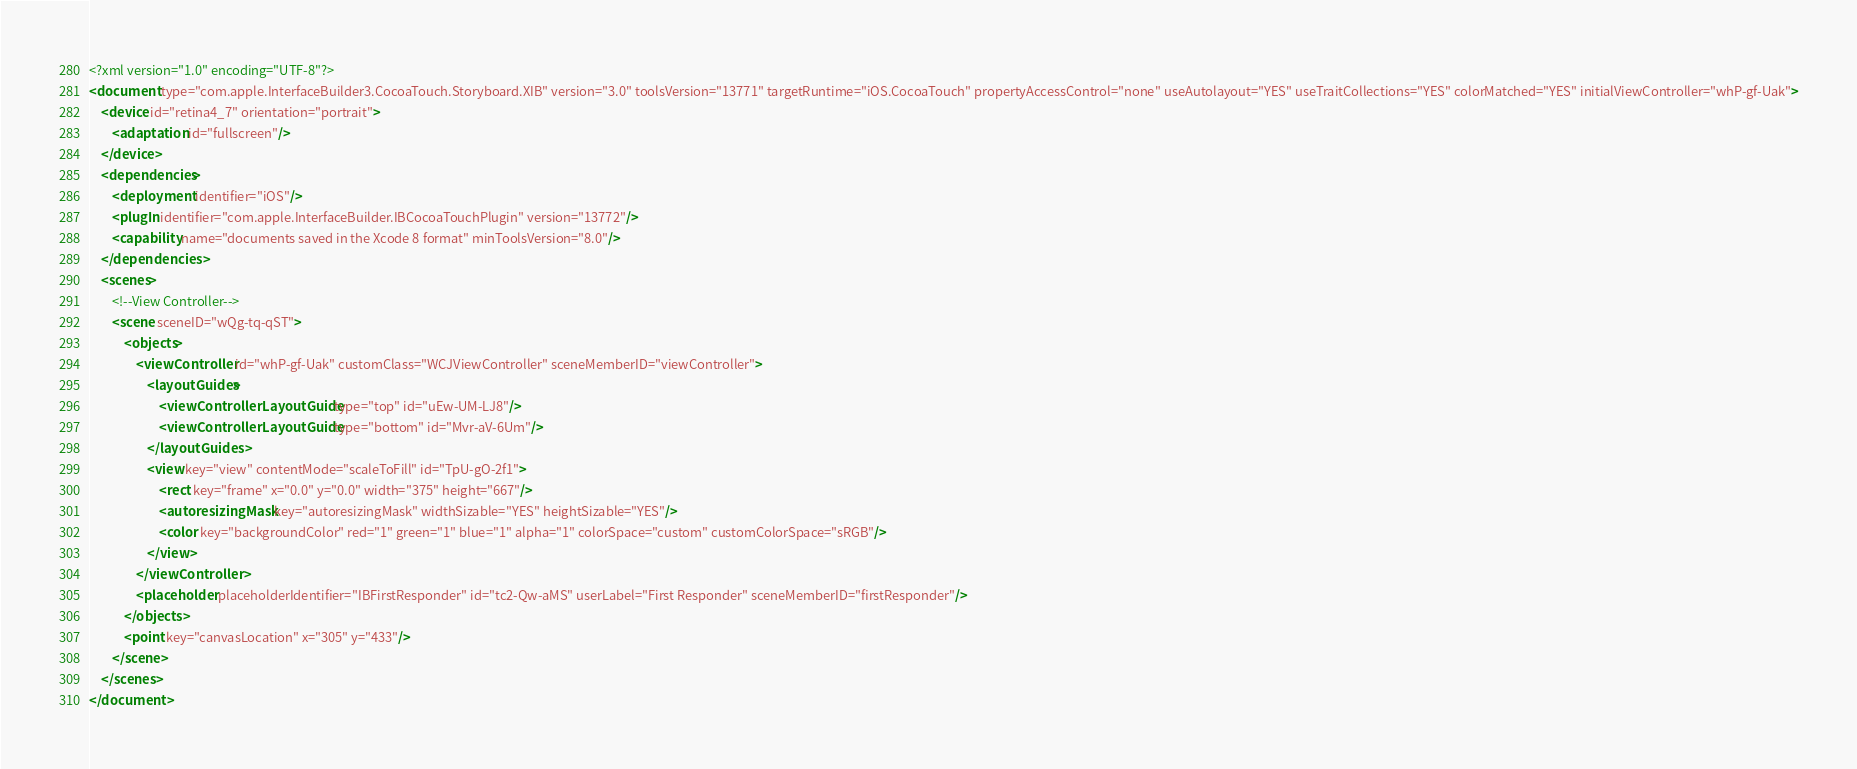<code> <loc_0><loc_0><loc_500><loc_500><_XML_><?xml version="1.0" encoding="UTF-8"?>
<document type="com.apple.InterfaceBuilder3.CocoaTouch.Storyboard.XIB" version="3.0" toolsVersion="13771" targetRuntime="iOS.CocoaTouch" propertyAccessControl="none" useAutolayout="YES" useTraitCollections="YES" colorMatched="YES" initialViewController="whP-gf-Uak">
    <device id="retina4_7" orientation="portrait">
        <adaptation id="fullscreen"/>
    </device>
    <dependencies>
        <deployment identifier="iOS"/>
        <plugIn identifier="com.apple.InterfaceBuilder.IBCocoaTouchPlugin" version="13772"/>
        <capability name="documents saved in the Xcode 8 format" minToolsVersion="8.0"/>
    </dependencies>
    <scenes>
        <!--View Controller-->
        <scene sceneID="wQg-tq-qST">
            <objects>
                <viewController id="whP-gf-Uak" customClass="WCJViewController" sceneMemberID="viewController">
                    <layoutGuides>
                        <viewControllerLayoutGuide type="top" id="uEw-UM-LJ8"/>
                        <viewControllerLayoutGuide type="bottom" id="Mvr-aV-6Um"/>
                    </layoutGuides>
                    <view key="view" contentMode="scaleToFill" id="TpU-gO-2f1">
                        <rect key="frame" x="0.0" y="0.0" width="375" height="667"/>
                        <autoresizingMask key="autoresizingMask" widthSizable="YES" heightSizable="YES"/>
                        <color key="backgroundColor" red="1" green="1" blue="1" alpha="1" colorSpace="custom" customColorSpace="sRGB"/>
                    </view>
                </viewController>
                <placeholder placeholderIdentifier="IBFirstResponder" id="tc2-Qw-aMS" userLabel="First Responder" sceneMemberID="firstResponder"/>
            </objects>
            <point key="canvasLocation" x="305" y="433"/>
        </scene>
    </scenes>
</document>
</code> 